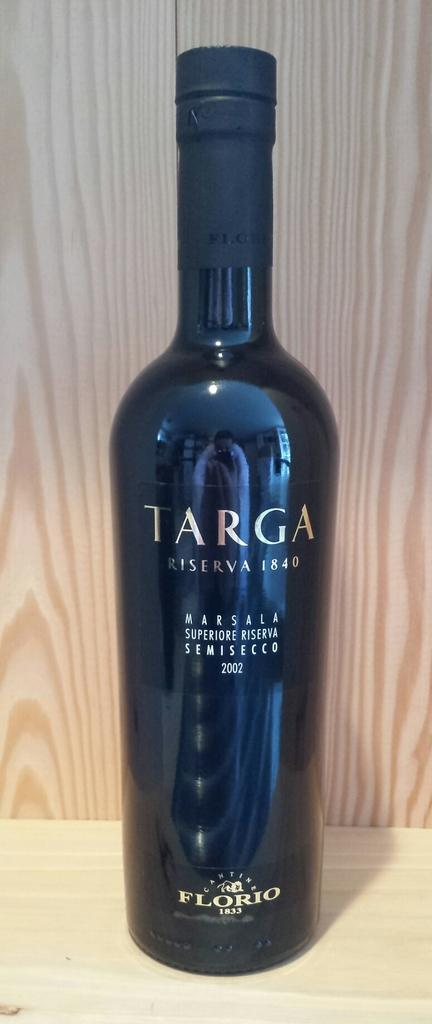<image>
Describe the image concisely. Long bottle of Targa wine from the year 1840. 